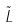<formula> <loc_0><loc_0><loc_500><loc_500>\tilde { L }</formula> 